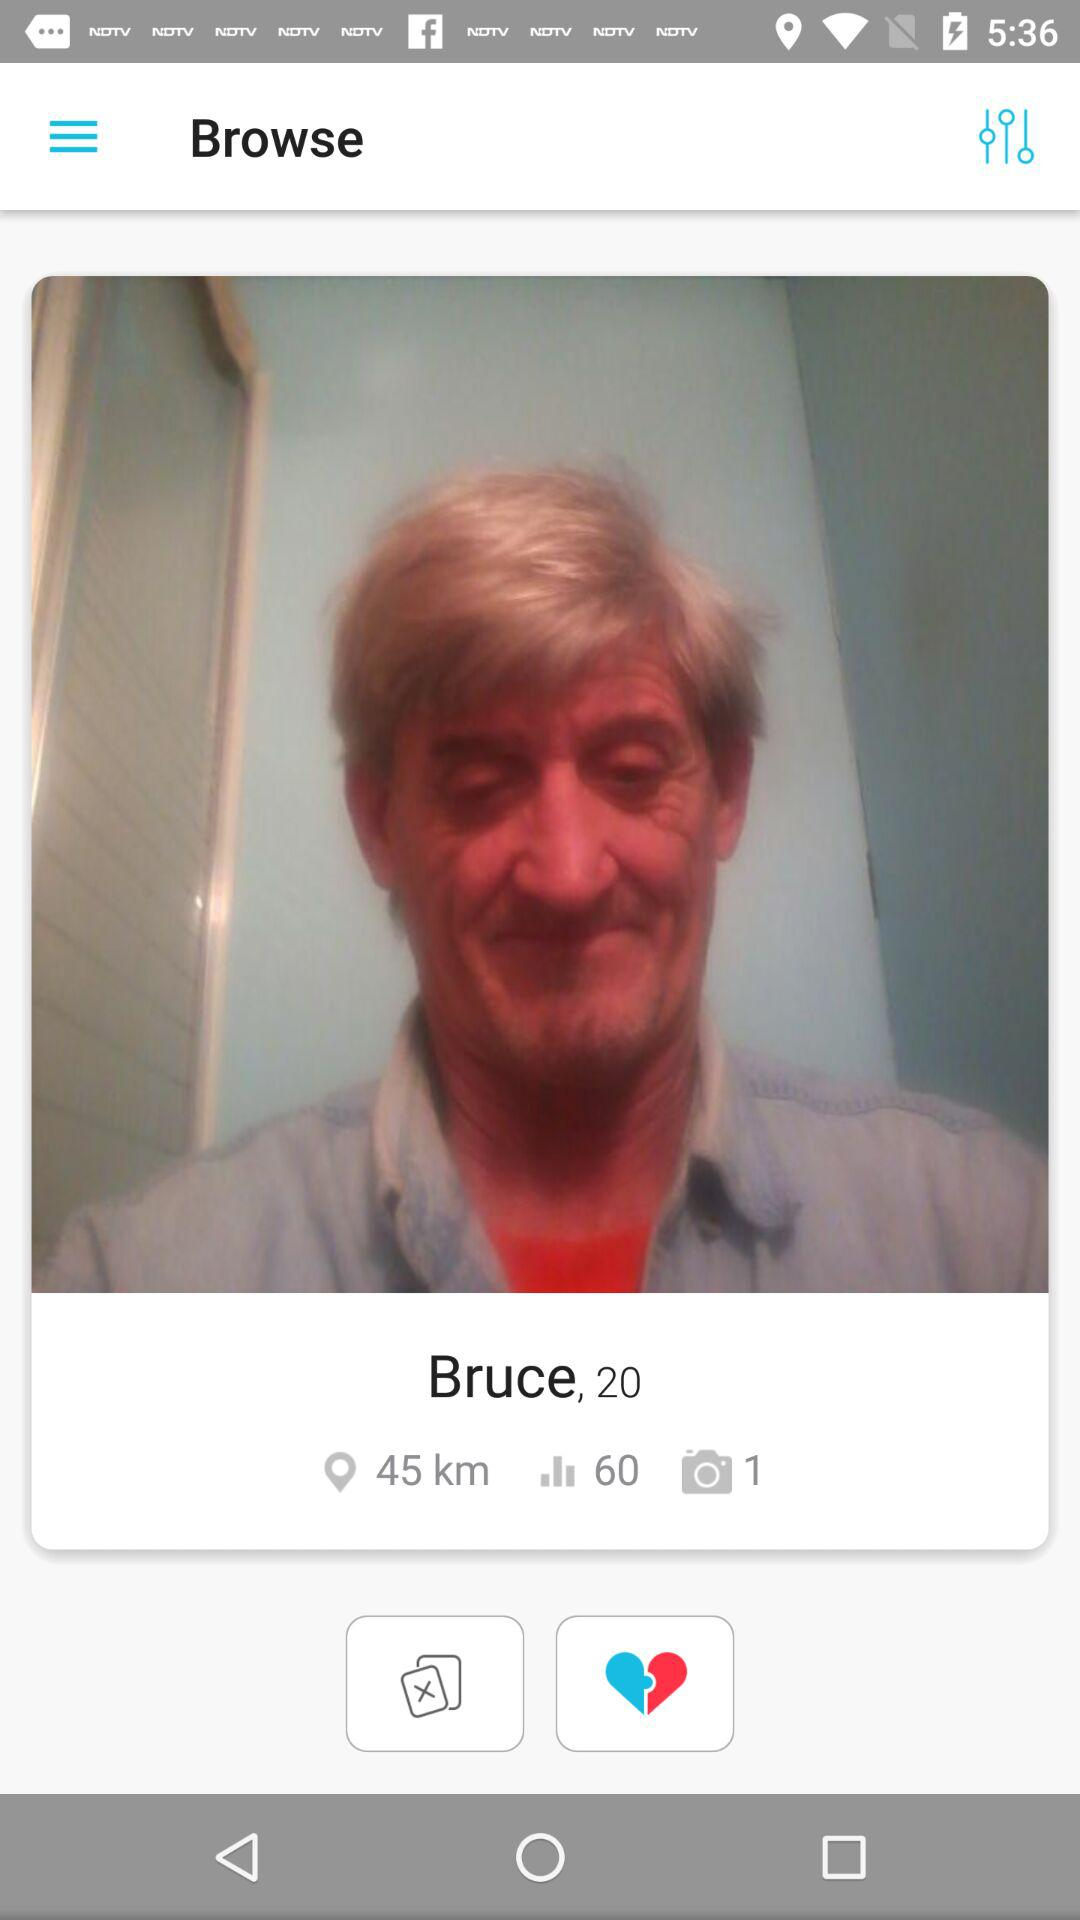In which city is the user?
When the provided information is insufficient, respond with <no answer>. <no answer> 